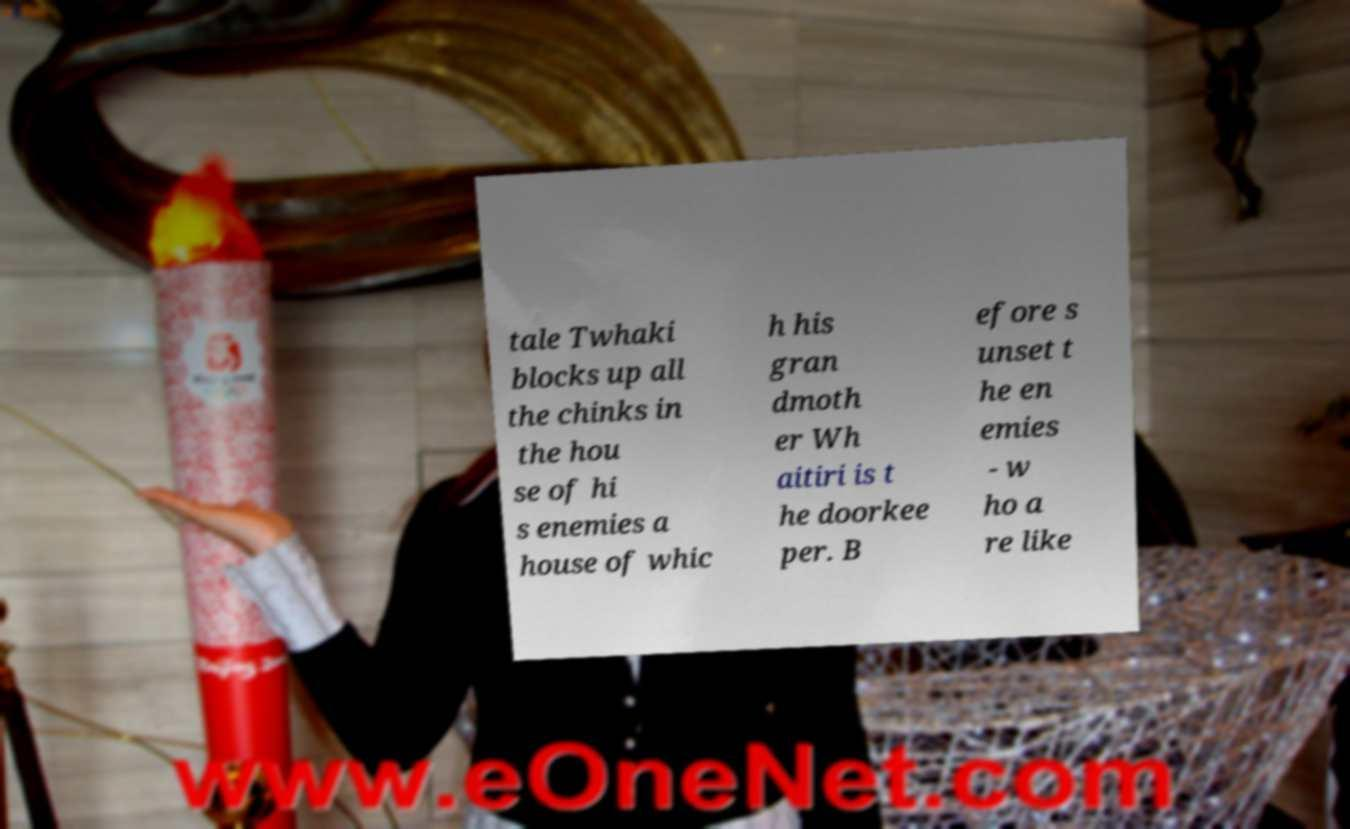Can you accurately transcribe the text from the provided image for me? tale Twhaki blocks up all the chinks in the hou se of hi s enemies a house of whic h his gran dmoth er Wh aitiri is t he doorkee per. B efore s unset t he en emies - w ho a re like 